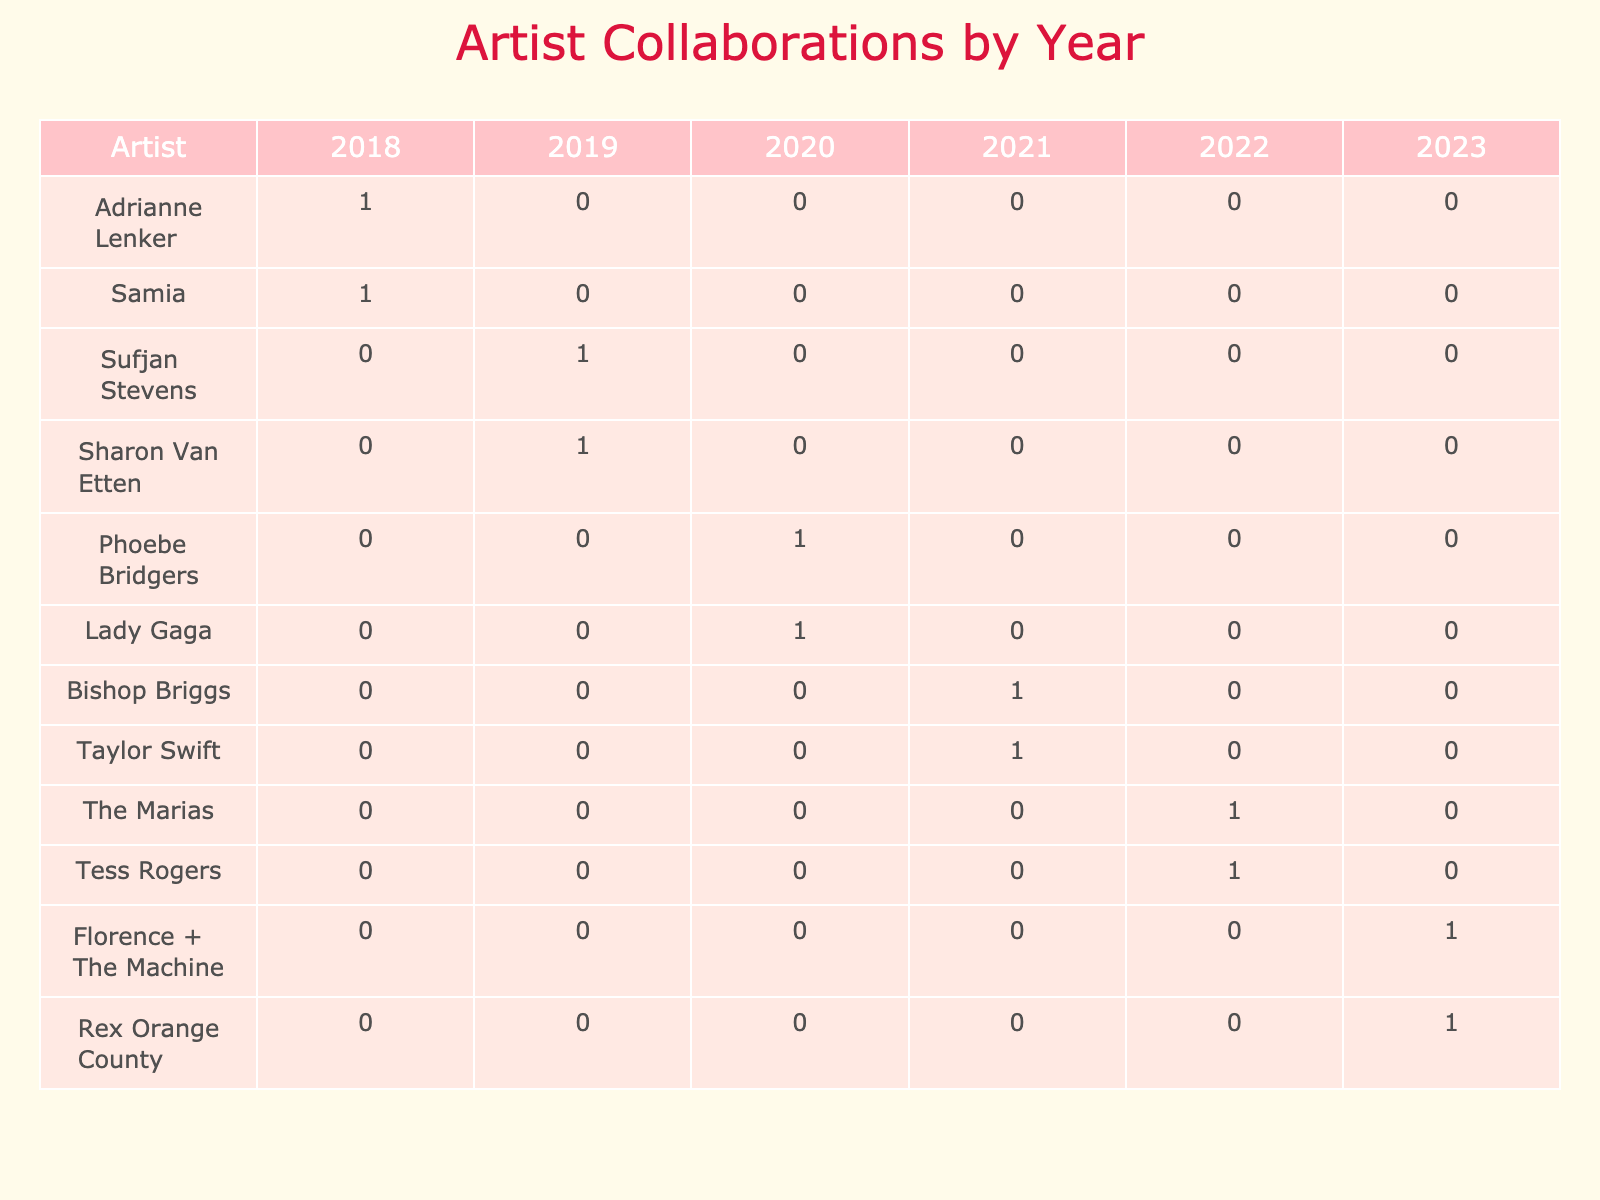How many collaborations did Phoebe Bridgers have in 2020? Looking at the table, we see that Phoebe Bridgers appears once in the year 2020. Therefore, she had 1 collaboration that year.
Answer: 1 Which artist had the most collaborations in 2019? In the table for 2019, Sufjan Stevens and Sharon Van Etten each have 1 collaboration, which is the highest count for that year. Therefore, both are tied for the most collaborations.
Answer: Sufjan Stevens and Sharon Van Etten Did any artist collaborate with more than one featured artist in the same year? The table shows that across all years, no artist has multiple collaborations listed with different featured artists in a single year. Therefore, the answer is no.
Answer: No Which year had the highest number of collaborations represented in the table? By analyzing the table, we can count the number of collaborations per year: 2018 has 2, 2019 has 2, 2020 has 2, 2021 has 2, 2022 has 2, and 2023 has 2. All years have the same number of collaborations, so there is no single year with more than the others.
Answer: All years are equal What is the total number of collaborations across all years? By adding up the number of collaborations from each year, we have: 2 (2018) + 2 (2019) + 2 (2020) + 2 (2021) + 2 (2022) + 2 (2023) = 12 collaborations in total.
Answer: 12 Which featured artist worked with the most different artists? In the table, Kevin Morby, Sasha Alex S, Vampire Weekend, Big Thief, Conor Oberst, Elton John, James Blake, Bon Iver, Tommy Genesis, Alvvays, Billie Eilish, and Jodie Abacus appear only once as featured artists. Therefore, none have multiple collaborations, making them all equal with 1 collaboration each.
Answer: No artist has multiple collaborations Are there any collaborations that involved artists from different genres? By examining the table, it's clear that tracks featuring artists with differing genres do exist. For instance, the collaboration with Lady Gaga (Pop) and Elton John (Pop) is a different genre compared to the others listed.
Answer: Yes, some collaborations involved different genres 